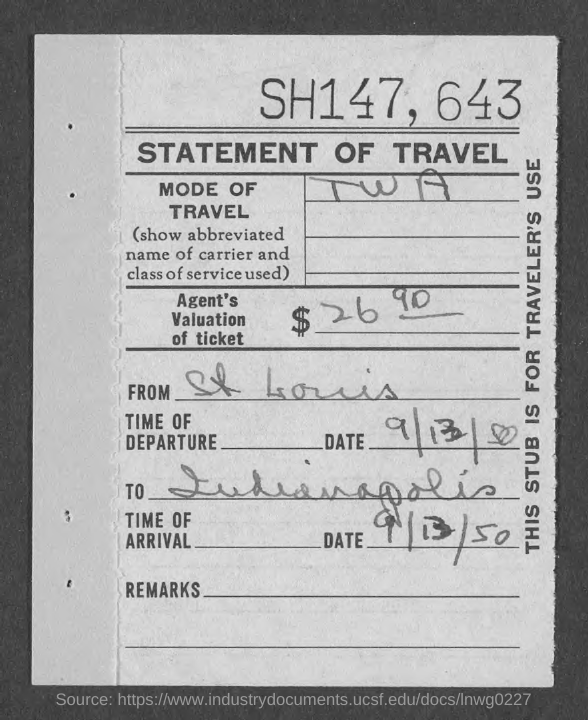Indicate a few pertinent items in this graphic. The mode of travel for TWA is... I, [your name], am from St. Louis. The date of departure is 9/13/50. The date of arrival is September 13, 1950. 